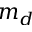<formula> <loc_0><loc_0><loc_500><loc_500>m _ { d }</formula> 